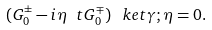Convert formula to latex. <formula><loc_0><loc_0><loc_500><loc_500>( G ^ { \pm } _ { 0 } - i \eta \ t G ^ { \mp } _ { 0 } ) \, \ k e t { \gamma ; \eta } = 0 .</formula> 